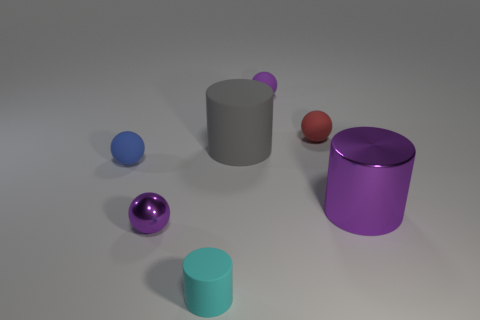What number of blue balls are made of the same material as the cyan thing?
Offer a very short reply. 1. Is the shape of the tiny purple thing that is right of the large gray matte object the same as the big thing on the left side of the red rubber object?
Ensure brevity in your answer.  No. There is a large cylinder that is in front of the big rubber object; what color is it?
Your answer should be compact. Purple. Are there any blue things that have the same shape as the small purple shiny object?
Keep it short and to the point. Yes. What is the cyan cylinder made of?
Offer a very short reply. Rubber. What size is the matte object that is on the left side of the red matte ball and behind the gray rubber thing?
Your answer should be compact. Small. What material is the big thing that is the same color as the metallic sphere?
Make the answer very short. Metal. How many large gray things are there?
Your response must be concise. 1. Are there fewer small cyan metallic spheres than tiny red matte things?
Make the answer very short. Yes. What is the material of the red sphere that is the same size as the purple metallic sphere?
Ensure brevity in your answer.  Rubber. 